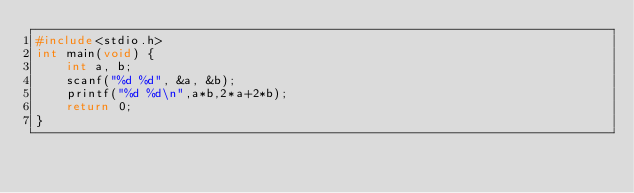<code> <loc_0><loc_0><loc_500><loc_500><_C_>#include<stdio.h>
int main(void) {
	int a, b;
	scanf("%d %d", &a, &b);
	printf("%d %d\n",a*b,2*a+2*b);
	return 0;
}
</code> 